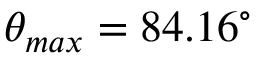<formula> <loc_0><loc_0><loc_500><loc_500>\theta _ { \max } = 8 4 . 1 6 ^ { \circ }</formula> 